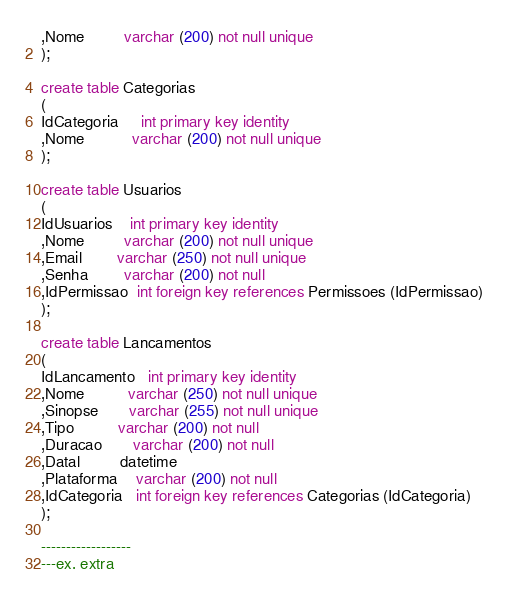<code> <loc_0><loc_0><loc_500><loc_500><_SQL_>,Nome         varchar (200) not null unique 
);

create table Categorias
(
IdCategoria     int primary key identity
,Nome           varchar (200) not null unique 
);

create table Usuarios
(
IdUsuarios    int primary key identity 
,Nome         varchar (200) not null unique 
,Email        varchar (250) not null unique 
,Senha        varchar (200) not null 
,IdPermissao  int foreign key references Permissoes (IdPermissao)
);

create table Lancamentos
(
IdLancamento   int primary key identity 
,Nome          varchar (250) not null unique 
,Sinopse       varchar (255) not null unique 
,Tipo          varchar (200) not null 
,Duracao       varchar (200) not null 
,Datal         datetime
,Plataforma    varchar (200) not null 
,IdCategoria   int foreign key references Categorias (IdCategoria)
);

------------------
---ex. extra


</code> 